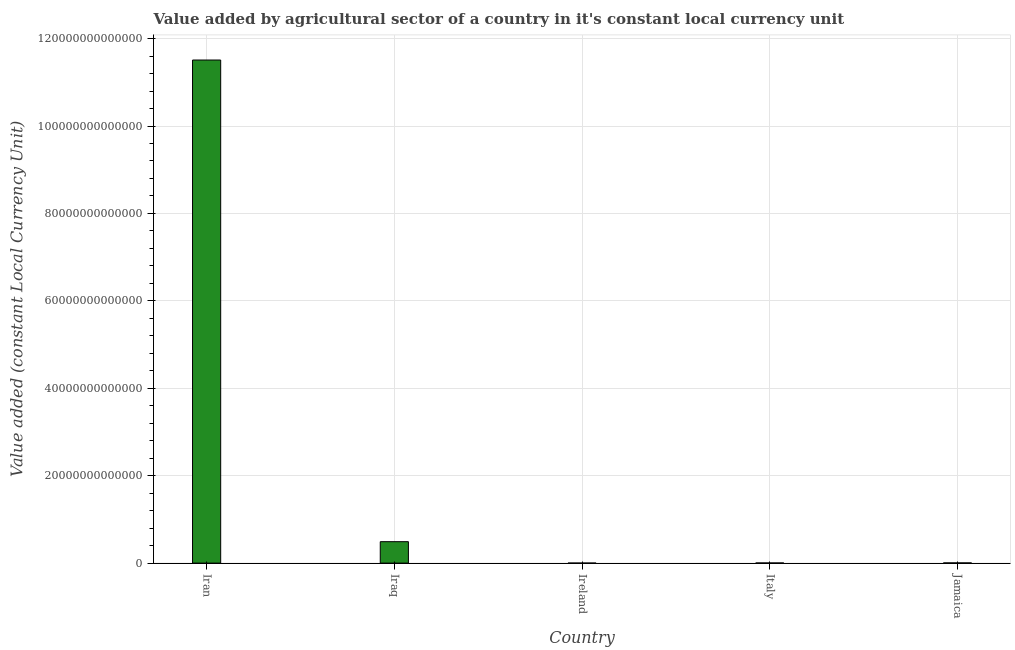Does the graph contain grids?
Give a very brief answer. Yes. What is the title of the graph?
Your answer should be compact. Value added by agricultural sector of a country in it's constant local currency unit. What is the label or title of the Y-axis?
Keep it short and to the point. Value added (constant Local Currency Unit). What is the value added by agriculture sector in Iraq?
Ensure brevity in your answer.  4.90e+12. Across all countries, what is the maximum value added by agriculture sector?
Your response must be concise. 1.15e+14. Across all countries, what is the minimum value added by agriculture sector?
Your answer should be very brief. 1.59e+09. In which country was the value added by agriculture sector maximum?
Your response must be concise. Iran. In which country was the value added by agriculture sector minimum?
Offer a very short reply. Ireland. What is the sum of the value added by agriculture sector?
Offer a very short reply. 1.20e+14. What is the difference between the value added by agriculture sector in Iraq and Ireland?
Offer a very short reply. 4.90e+12. What is the average value added by agriculture sector per country?
Ensure brevity in your answer.  2.40e+13. What is the median value added by agriculture sector?
Your response must be concise. 4.37e+1. What is the ratio of the value added by agriculture sector in Ireland to that in Jamaica?
Provide a succinct answer. 0.04. What is the difference between the highest and the second highest value added by agriculture sector?
Offer a very short reply. 1.10e+14. Is the sum of the value added by agriculture sector in Iran and Jamaica greater than the maximum value added by agriculture sector across all countries?
Offer a terse response. Yes. What is the difference between the highest and the lowest value added by agriculture sector?
Make the answer very short. 1.15e+14. How many bars are there?
Your answer should be compact. 5. Are all the bars in the graph horizontal?
Your answer should be compact. No. What is the difference between two consecutive major ticks on the Y-axis?
Ensure brevity in your answer.  2.00e+13. Are the values on the major ticks of Y-axis written in scientific E-notation?
Provide a short and direct response. No. What is the Value added (constant Local Currency Unit) of Iran?
Your answer should be compact. 1.15e+14. What is the Value added (constant Local Currency Unit) in Iraq?
Provide a succinct answer. 4.90e+12. What is the Value added (constant Local Currency Unit) of Ireland?
Offer a very short reply. 1.59e+09. What is the Value added (constant Local Currency Unit) of Italy?
Your response must be concise. 2.83e+1. What is the Value added (constant Local Currency Unit) in Jamaica?
Provide a succinct answer. 4.37e+1. What is the difference between the Value added (constant Local Currency Unit) in Iran and Iraq?
Offer a terse response. 1.10e+14. What is the difference between the Value added (constant Local Currency Unit) in Iran and Ireland?
Your answer should be very brief. 1.15e+14. What is the difference between the Value added (constant Local Currency Unit) in Iran and Italy?
Offer a terse response. 1.15e+14. What is the difference between the Value added (constant Local Currency Unit) in Iran and Jamaica?
Provide a succinct answer. 1.15e+14. What is the difference between the Value added (constant Local Currency Unit) in Iraq and Ireland?
Keep it short and to the point. 4.90e+12. What is the difference between the Value added (constant Local Currency Unit) in Iraq and Italy?
Give a very brief answer. 4.87e+12. What is the difference between the Value added (constant Local Currency Unit) in Iraq and Jamaica?
Offer a very short reply. 4.86e+12. What is the difference between the Value added (constant Local Currency Unit) in Ireland and Italy?
Keep it short and to the point. -2.67e+1. What is the difference between the Value added (constant Local Currency Unit) in Ireland and Jamaica?
Offer a terse response. -4.21e+1. What is the difference between the Value added (constant Local Currency Unit) in Italy and Jamaica?
Your answer should be compact. -1.54e+1. What is the ratio of the Value added (constant Local Currency Unit) in Iran to that in Iraq?
Give a very brief answer. 23.5. What is the ratio of the Value added (constant Local Currency Unit) in Iran to that in Ireland?
Offer a very short reply. 7.24e+04. What is the ratio of the Value added (constant Local Currency Unit) in Iran to that in Italy?
Offer a very short reply. 4065.16. What is the ratio of the Value added (constant Local Currency Unit) in Iran to that in Jamaica?
Offer a terse response. 2631.65. What is the ratio of the Value added (constant Local Currency Unit) in Iraq to that in Ireland?
Your response must be concise. 3081.2. What is the ratio of the Value added (constant Local Currency Unit) in Iraq to that in Italy?
Make the answer very short. 173.02. What is the ratio of the Value added (constant Local Currency Unit) in Iraq to that in Jamaica?
Make the answer very short. 112. What is the ratio of the Value added (constant Local Currency Unit) in Ireland to that in Italy?
Your response must be concise. 0.06. What is the ratio of the Value added (constant Local Currency Unit) in Ireland to that in Jamaica?
Keep it short and to the point. 0.04. What is the ratio of the Value added (constant Local Currency Unit) in Italy to that in Jamaica?
Your response must be concise. 0.65. 